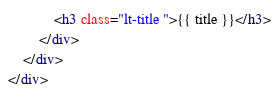<code> <loc_0><loc_0><loc_500><loc_500><_HTML_>            <h3 class="lt-title ">{{ title }}</h3>
        </div>
    </div>
</div>
</code> 